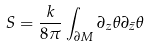<formula> <loc_0><loc_0><loc_500><loc_500>S = \frac { k } { 8 \pi } \int _ { \partial M } \partial _ { z } \theta \partial _ { \bar { z } } \theta</formula> 